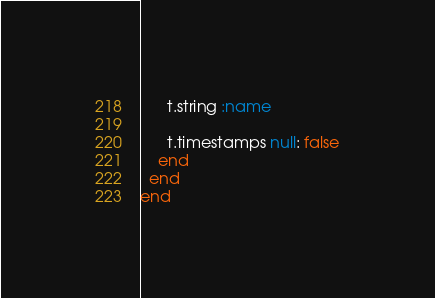Convert code to text. <code><loc_0><loc_0><loc_500><loc_500><_Ruby_>      t.string :name

      t.timestamps null: false
    end
  end
end
</code> 